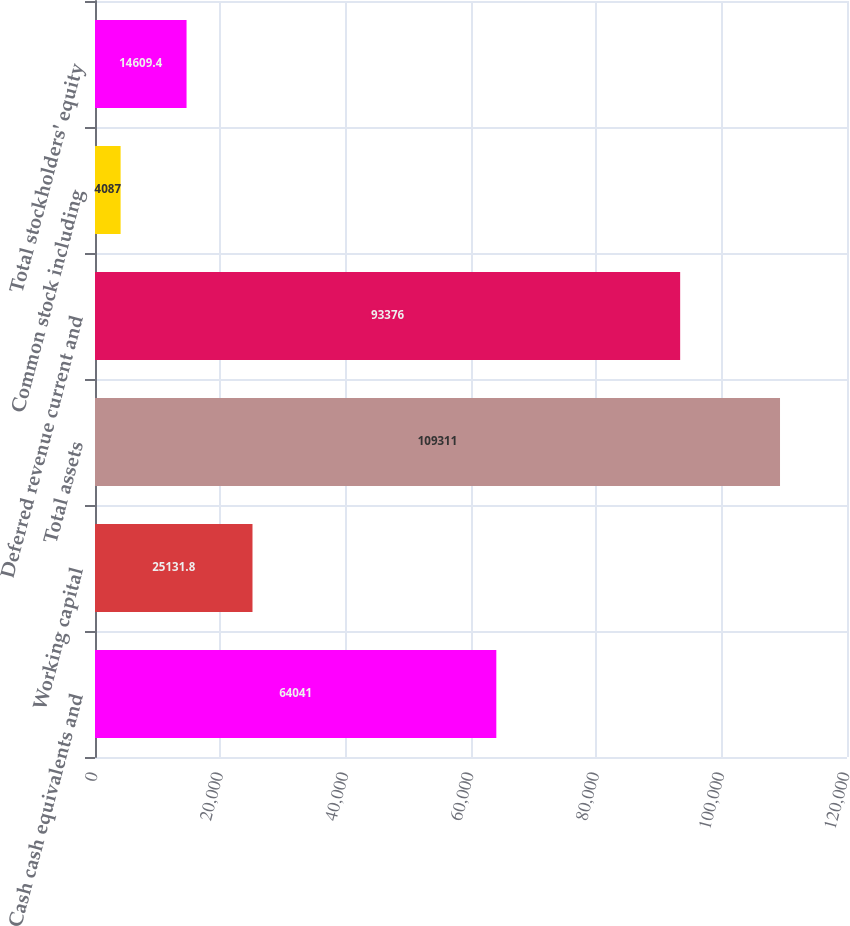Convert chart to OTSL. <chart><loc_0><loc_0><loc_500><loc_500><bar_chart><fcel>Cash cash equivalents and<fcel>Working capital<fcel>Total assets<fcel>Deferred revenue current and<fcel>Common stock including<fcel>Total stockholders' equity<nl><fcel>64041<fcel>25131.8<fcel>109311<fcel>93376<fcel>4087<fcel>14609.4<nl></chart> 